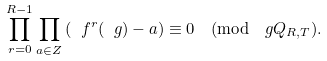<formula> <loc_0><loc_0><loc_500><loc_500>\prod _ { r = 0 } ^ { R - 1 } \prod _ { a \in Z } \left ( \ f ^ { r } ( \ g ) - a \right ) \equiv 0 \pmod { \ g Q _ { R , T } } .</formula> 